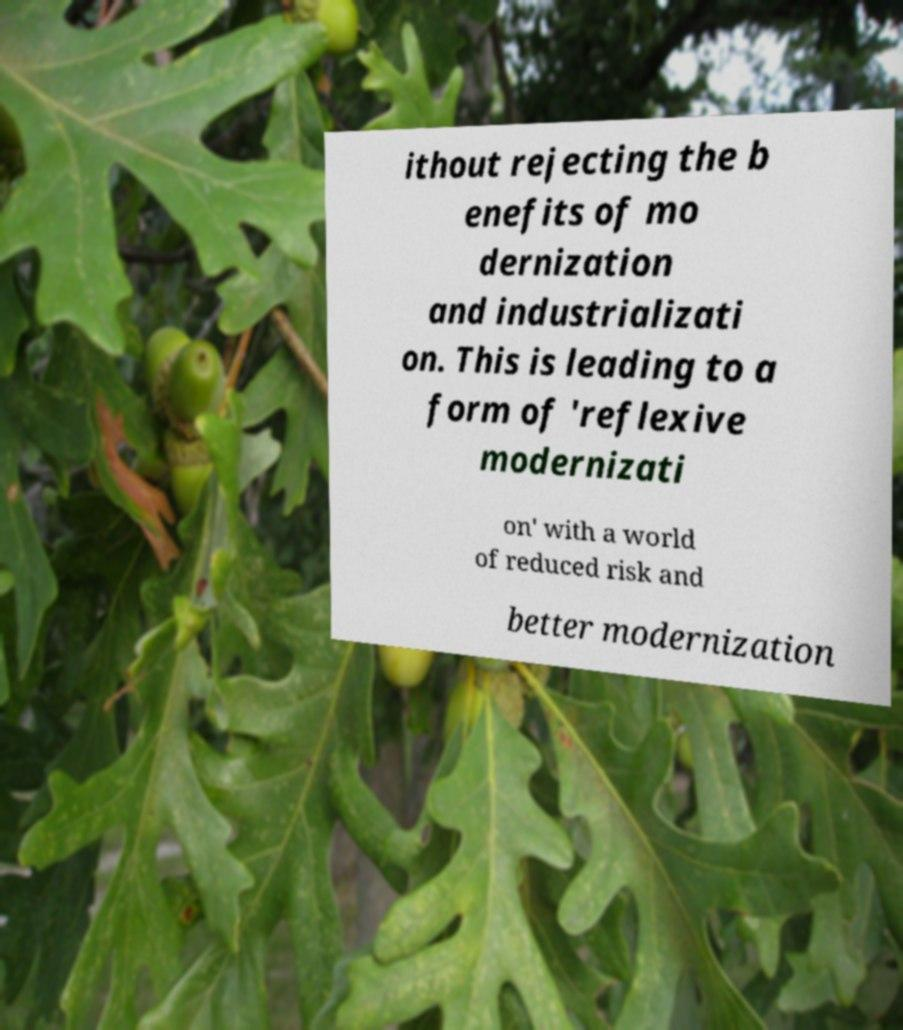Please read and relay the text visible in this image. What does it say? ithout rejecting the b enefits of mo dernization and industrializati on. This is leading to a form of 'reflexive modernizati on' with a world of reduced risk and better modernization 